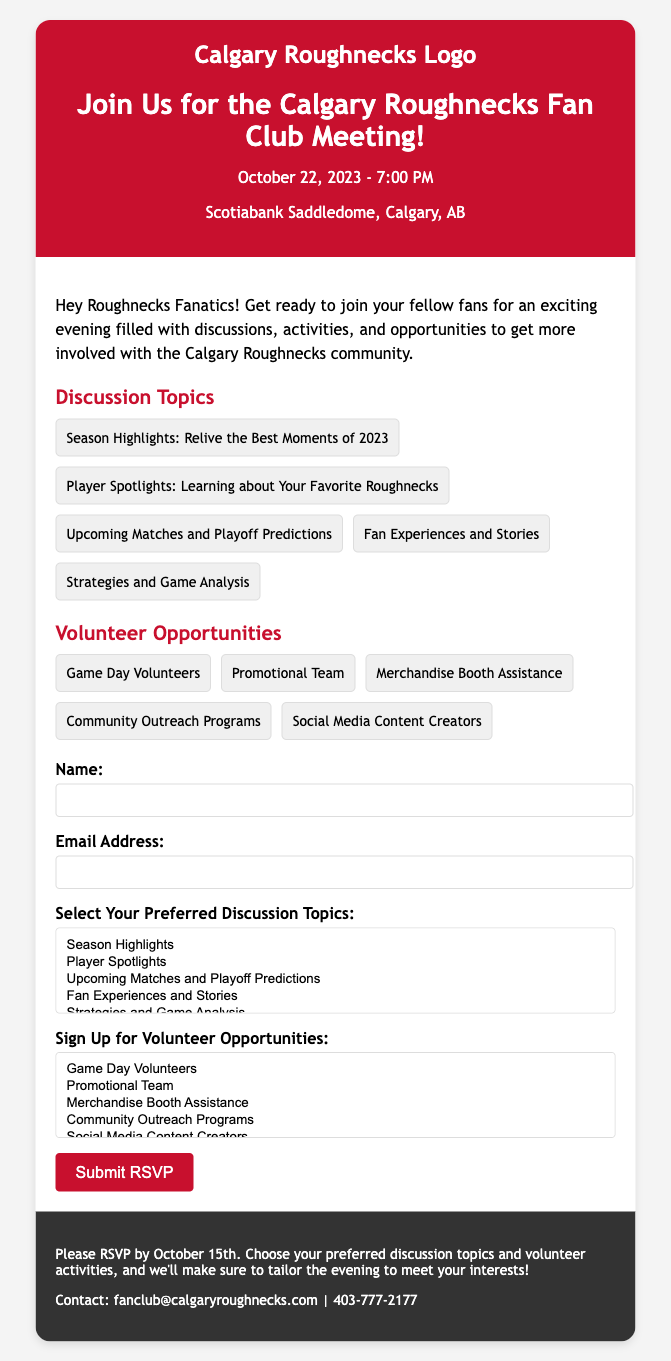What is the name of the event? The event title is clearly mentioned in the document header, which is "Join Us for the Calgary Roughnecks Fan Club Meeting!"
Answer: Join Us for the Calgary Roughnecks Fan Club Meeting! What date is the meeting scheduled for? The date of the meeting is provided in the date-time section of the header, specifically stating "October 22, 2023."
Answer: October 22, 2023 At what time will the meeting take place? The time of the meeting is listed alongside the date in the header, which reads "7:00 PM."
Answer: 7:00 PM Where is the location of the meeting? The location can be found in the location section of the header, which is "Scotiabank Saddledome, Calgary, AB."
Answer: Scotiabank Saddledome, Calgary, AB What are the discussion topics available? The discussion topics are listed under a specific section titled "Discussion Topics," including five options highlighted in the document.
Answer: Season Highlights, Player Spotlights, Upcoming Matches and Playoff Predictions, Fan Experiences and Stories, Strategies and Game Analysis By when should attendees RSVP? The RSVP deadline is provided in the footer of the document, stating "Please RSVP by October 15th."
Answer: October 15th What is one volunteer opportunity mentioned? An example of a volunteer opportunity is provided in the section titled "Volunteer Opportunities," which contains five options as well.
Answer: Game Day Volunteers What is the contact email provided in the document? The contact email address is given at the end of the document in the footer section, which reads "fanclub@calgaryroughnecks.com."
Answer: fanclub@calgaryroughnecks.com 